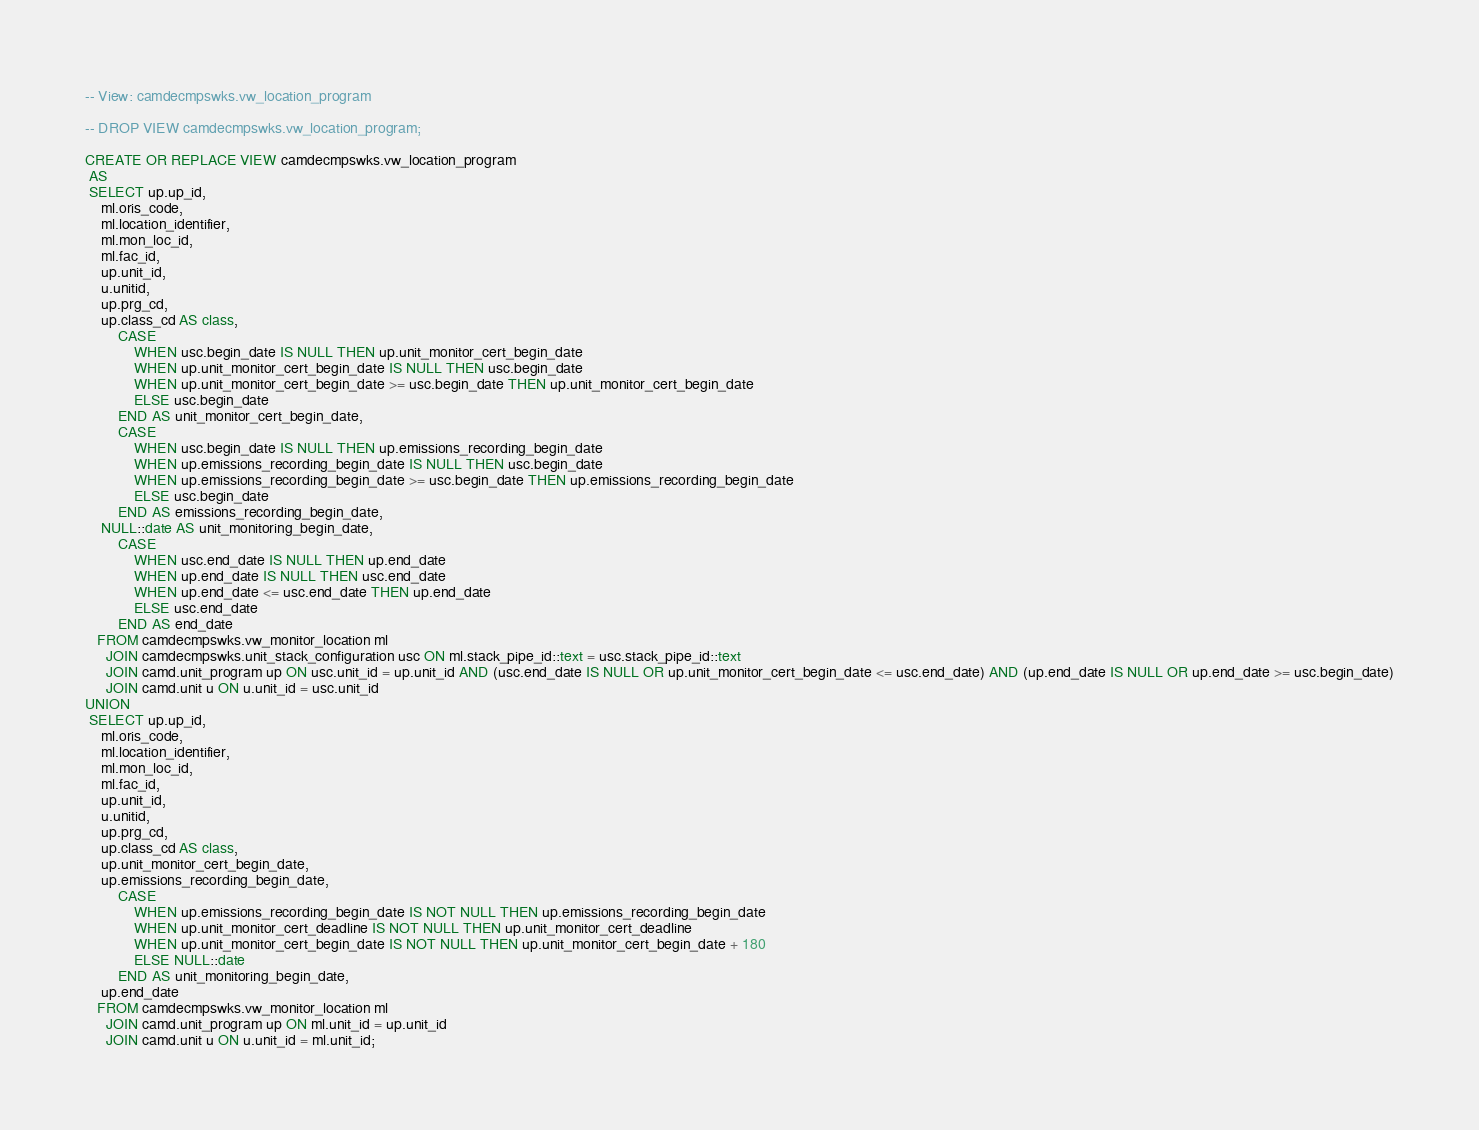<code> <loc_0><loc_0><loc_500><loc_500><_SQL_>-- View: camdecmpswks.vw_location_program

-- DROP VIEW camdecmpswks.vw_location_program;

CREATE OR REPLACE VIEW camdecmpswks.vw_location_program
 AS
 SELECT up.up_id,
    ml.oris_code,
    ml.location_identifier,
    ml.mon_loc_id,
    ml.fac_id,
    up.unit_id,
    u.unitid,
    up.prg_cd,
    up.class_cd AS class,
        CASE
            WHEN usc.begin_date IS NULL THEN up.unit_monitor_cert_begin_date
            WHEN up.unit_monitor_cert_begin_date IS NULL THEN usc.begin_date
            WHEN up.unit_monitor_cert_begin_date >= usc.begin_date THEN up.unit_monitor_cert_begin_date
            ELSE usc.begin_date
        END AS unit_monitor_cert_begin_date,
        CASE
            WHEN usc.begin_date IS NULL THEN up.emissions_recording_begin_date
            WHEN up.emissions_recording_begin_date IS NULL THEN usc.begin_date
            WHEN up.emissions_recording_begin_date >= usc.begin_date THEN up.emissions_recording_begin_date
            ELSE usc.begin_date
        END AS emissions_recording_begin_date,
    NULL::date AS unit_monitoring_begin_date,
        CASE
            WHEN usc.end_date IS NULL THEN up.end_date
            WHEN up.end_date IS NULL THEN usc.end_date
            WHEN up.end_date <= usc.end_date THEN up.end_date
            ELSE usc.end_date
        END AS end_date
   FROM camdecmpswks.vw_monitor_location ml
     JOIN camdecmpswks.unit_stack_configuration usc ON ml.stack_pipe_id::text = usc.stack_pipe_id::text
     JOIN camd.unit_program up ON usc.unit_id = up.unit_id AND (usc.end_date IS NULL OR up.unit_monitor_cert_begin_date <= usc.end_date) AND (up.end_date IS NULL OR up.end_date >= usc.begin_date)
     JOIN camd.unit u ON u.unit_id = usc.unit_id
UNION
 SELECT up.up_id,
    ml.oris_code,
    ml.location_identifier,
    ml.mon_loc_id,
    ml.fac_id,
    up.unit_id,
    u.unitid,
    up.prg_cd,
    up.class_cd AS class,
    up.unit_monitor_cert_begin_date,
    up.emissions_recording_begin_date,
        CASE
            WHEN up.emissions_recording_begin_date IS NOT NULL THEN up.emissions_recording_begin_date
            WHEN up.unit_monitor_cert_deadline IS NOT NULL THEN up.unit_monitor_cert_deadline
            WHEN up.unit_monitor_cert_begin_date IS NOT NULL THEN up.unit_monitor_cert_begin_date + 180
            ELSE NULL::date
        END AS unit_monitoring_begin_date,
    up.end_date
   FROM camdecmpswks.vw_monitor_location ml
     JOIN camd.unit_program up ON ml.unit_id = up.unit_id
     JOIN camd.unit u ON u.unit_id = ml.unit_id;
</code> 